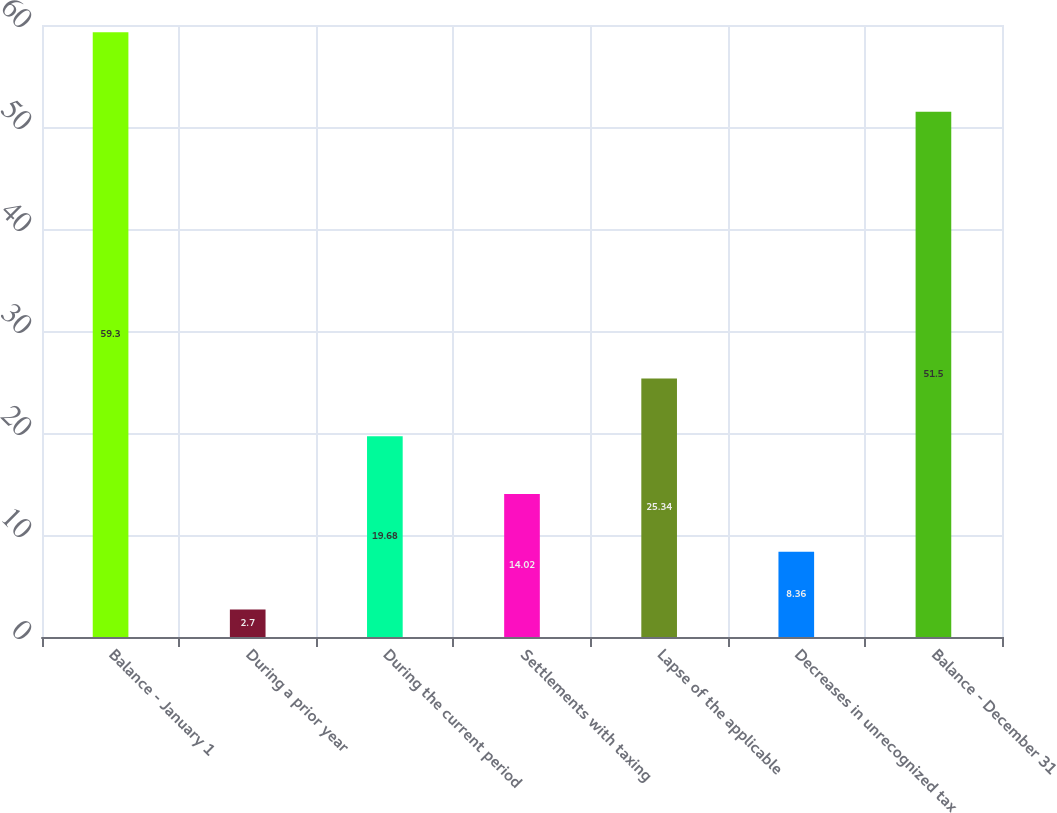Convert chart to OTSL. <chart><loc_0><loc_0><loc_500><loc_500><bar_chart><fcel>Balance - January 1<fcel>During a prior year<fcel>During the current period<fcel>Settlements with taxing<fcel>Lapse of the applicable<fcel>Decreases in unrecognized tax<fcel>Balance - December 31<nl><fcel>59.3<fcel>2.7<fcel>19.68<fcel>14.02<fcel>25.34<fcel>8.36<fcel>51.5<nl></chart> 